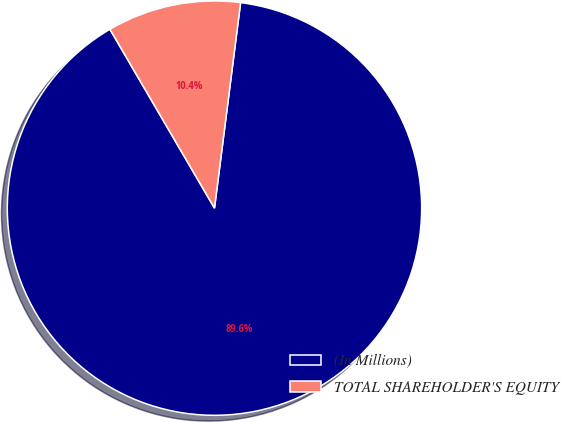Convert chart. <chart><loc_0><loc_0><loc_500><loc_500><pie_chart><fcel>(In Millions)<fcel>TOTAL SHAREHOLDER'S EQUITY<nl><fcel>89.57%<fcel>10.43%<nl></chart> 